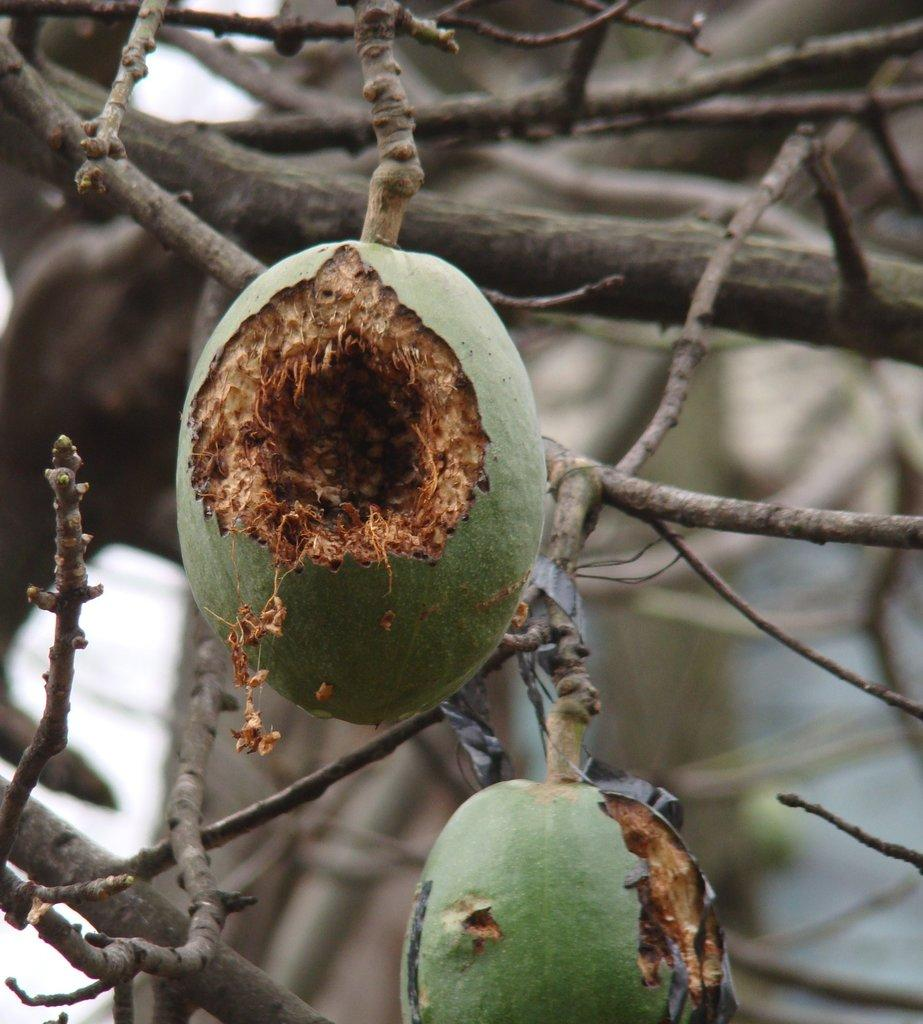What type of vegetation can be seen in the image? There are trees in the image. What is special about these trees? The trees have fruits on them. Can you tell me how many jellyfish are swimming in the trees in the image? There are no jellyfish present in the image; it features trees with fruits on them. What type of guide is available for the distribution of fruits in the image? There is no guide or distribution system mentioned in the image; it simply shows trees with fruits. 